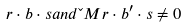<formula> <loc_0><loc_0><loc_500><loc_500>r \cdot b \cdot s a n d \L M { r \cdot b ^ { \prime } \cdot s } \ne 0</formula> 